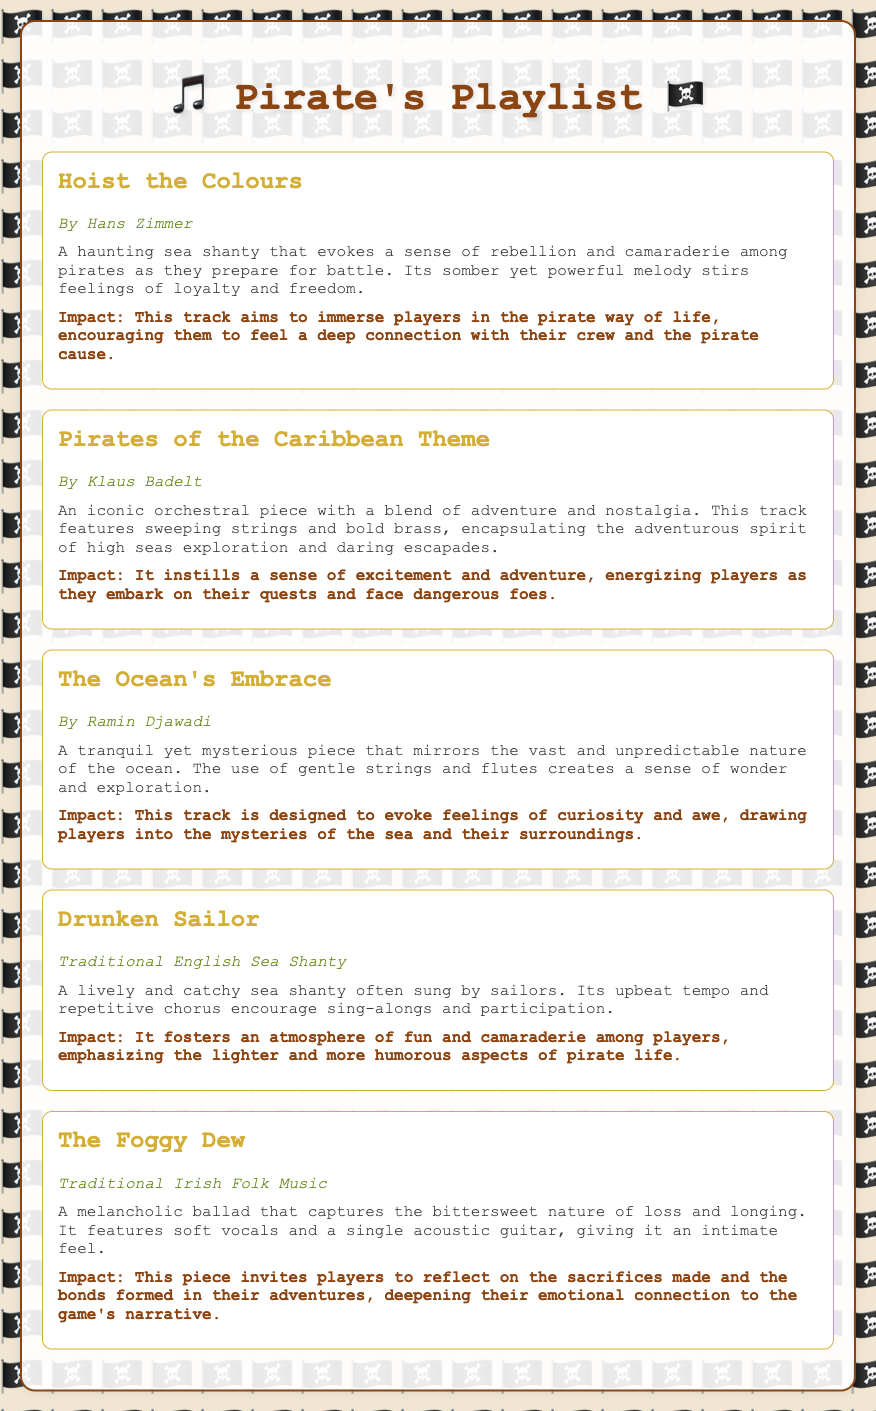What is the title of the first track? The title of the first track is found at the top of the first track information section.
Answer: Hoist the Colours Who is the artist for "Drunken Sailor"? The artist for "Drunken Sailor" is mentioned at the beginning of its corresponding section.
Answer: Traditional English Sea Shanty What type of music is "The Foggy Dew"? The type of music is outlined in the description paragraph under the title "The Foggy Dew."
Answer: Traditional Irish Folk Music Which track is described as having a tranquil yet mysterious piece? This information can be deduced from the description of "The Ocean's Embrace."
Answer: The Ocean's Embrace How does the track "Hoist the Colours" impact players? The impact of the track is specified in the impact paragraph following its description.
Answer: Encouraging them to feel a deep connection with their crew and the pirate cause What emotion does "The Ocean's Embrace" aim to evoke? The intended emotional response is stated in the track's impact section.
Answer: Curiosity and awe What is the primary theme of the "Pirates of the Caribbean Theme"? The theme can be inferred from the description, which highlights its adventurous nature.
Answer: Adventure and nostalgia How many tracks are listed in the selection? The total number of tracks can be counted within the track sections of the document.
Answer: Five 